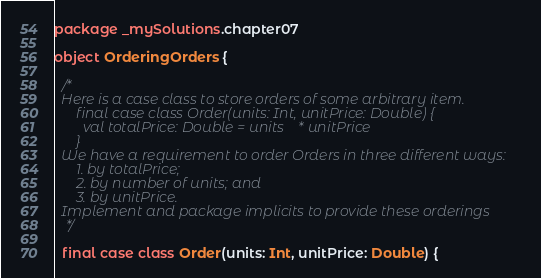<code> <loc_0><loc_0><loc_500><loc_500><_Scala_>package _mySolutions.chapter07

object OrderingOrders {

  /*
  Here is a case class to store orders of some arbitrary item.
      final case class Order(units: Int, unitPrice: Double) {
        val totalPrice: Double = units * unitPrice
      }
  We have a requirement to order Orders in three different ways:
      1. by totalPrice;
      2. by number of units; and
      3. by unitPrice.
  Implement and package implicits to provide these orderings
   */

  final case class Order(units: Int, unitPrice: Double) {</code> 